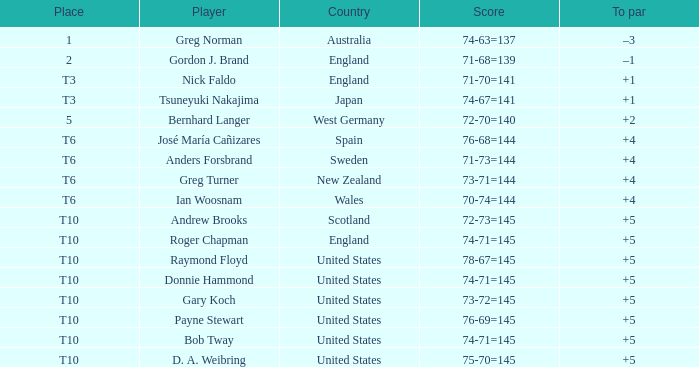Which player scored 76-68=144? José María Cañizares. 